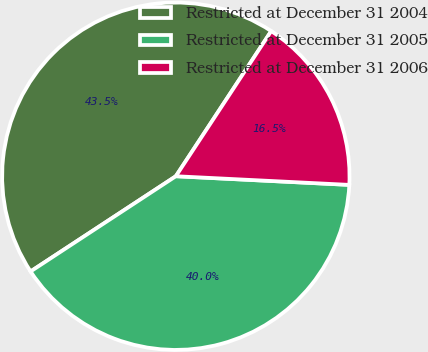Convert chart to OTSL. <chart><loc_0><loc_0><loc_500><loc_500><pie_chart><fcel>Restricted at December 31 2004<fcel>Restricted at December 31 2005<fcel>Restricted at December 31 2006<nl><fcel>43.49%<fcel>39.97%<fcel>16.54%<nl></chart> 